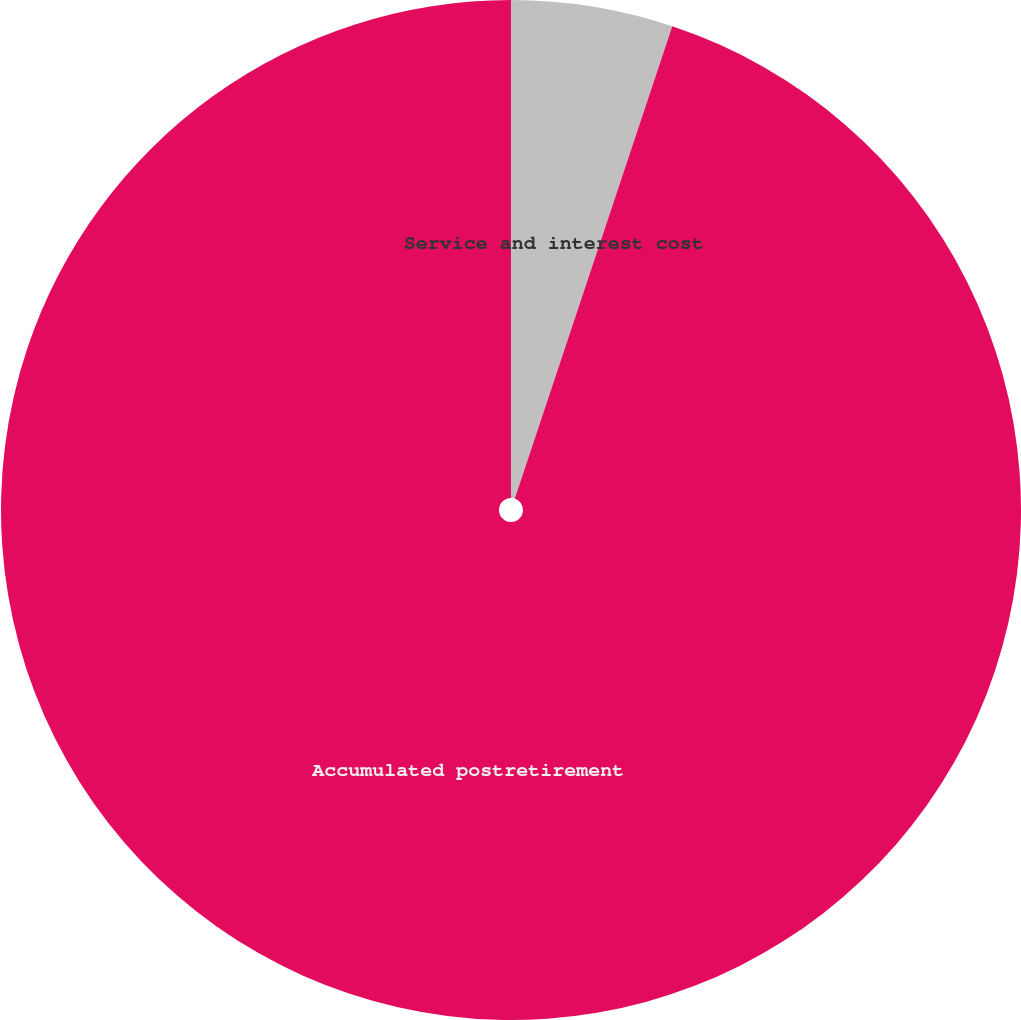<chart> <loc_0><loc_0><loc_500><loc_500><pie_chart><fcel>Service and interest cost<fcel>Accumulated postretirement<nl><fcel>5.12%<fcel>94.88%<nl></chart> 